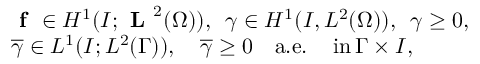Convert formula to latex. <formula><loc_0><loc_0><loc_500><loc_500>\begin{array} { r l } & { f \in H ^ { 1 } ( I ; L ^ { 2 } ( \Omega ) ) , \, \gamma \in H ^ { 1 } ( I , L ^ { 2 } ( \Omega ) ) , \, \gamma \geq 0 , } \\ & { \overline { \gamma } \in L ^ { 1 } ( I ; L ^ { 2 } ( \Gamma ) ) , \quad \overline { \gamma } \geq 0 \quad a . e . \, i n \, \Gamma \times I , } \end{array}</formula> 